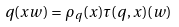Convert formula to latex. <formula><loc_0><loc_0><loc_500><loc_500>q ( x w ) = \rho _ { q } ( x ) \tau ( q , x ) ( w )</formula> 